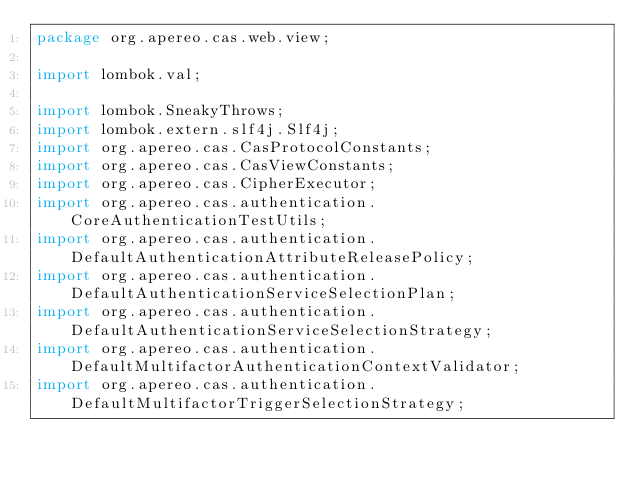<code> <loc_0><loc_0><loc_500><loc_500><_Java_>package org.apereo.cas.web.view;

import lombok.val;

import lombok.SneakyThrows;
import lombok.extern.slf4j.Slf4j;
import org.apereo.cas.CasProtocolConstants;
import org.apereo.cas.CasViewConstants;
import org.apereo.cas.CipherExecutor;
import org.apereo.cas.authentication.CoreAuthenticationTestUtils;
import org.apereo.cas.authentication.DefaultAuthenticationAttributeReleasePolicy;
import org.apereo.cas.authentication.DefaultAuthenticationServiceSelectionPlan;
import org.apereo.cas.authentication.DefaultAuthenticationServiceSelectionStrategy;
import org.apereo.cas.authentication.DefaultMultifactorAuthenticationContextValidator;
import org.apereo.cas.authentication.DefaultMultifactorTriggerSelectionStrategy;</code> 